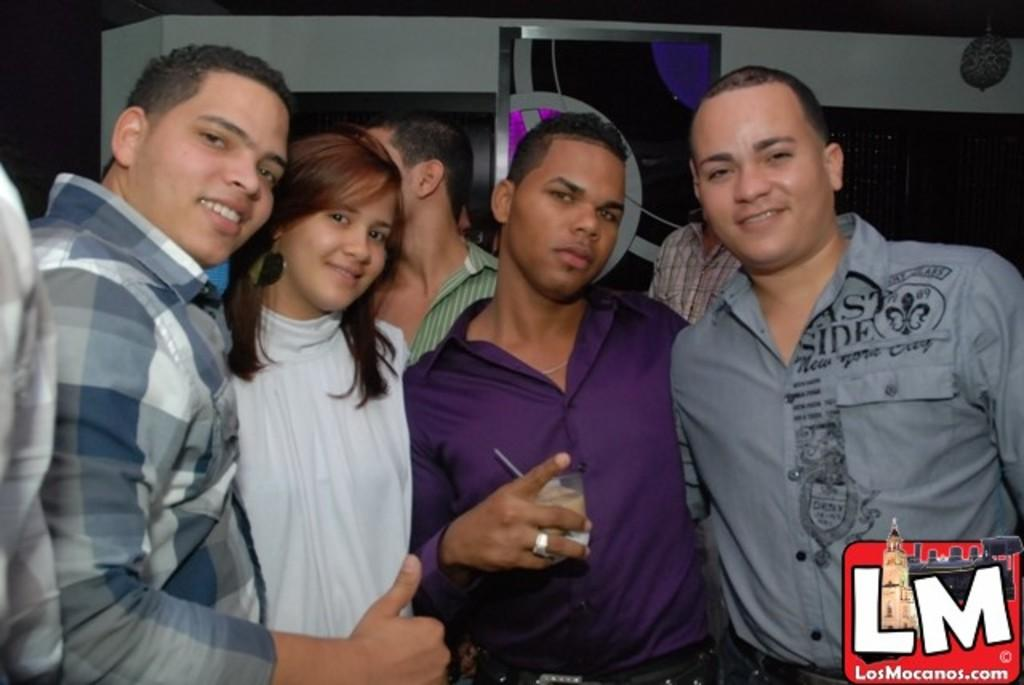What are the people in the image doing? The people in the image are standing. Can you describe what one person is holding? One person is holding something, but the specific object is not clear from the image. How can you differentiate the people in the image? The people are wearing different color dresses. What can be seen in the background of the image? There is a colorful board and a wall visible in the image. What type of support can be seen provided by the rat in the image? There is no rat present in the image, so no support can be provided by a rat. How many yams are visible in the image? There are no yams present in the image. 